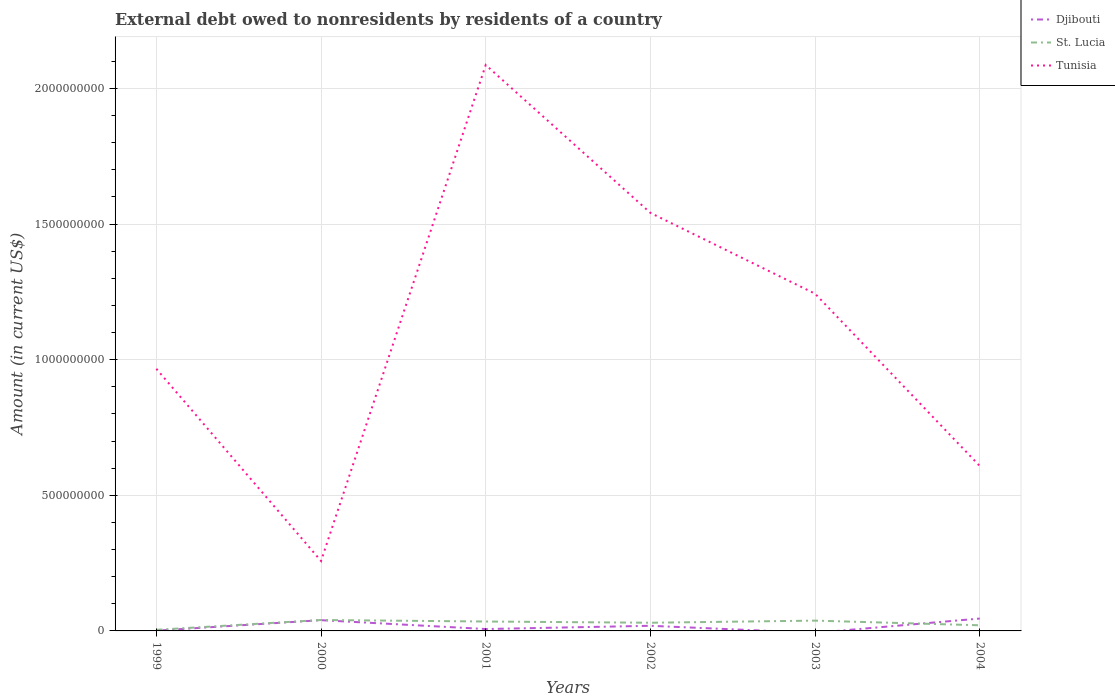Does the line corresponding to Tunisia intersect with the line corresponding to Djibouti?
Your answer should be very brief. No. Across all years, what is the maximum external debt owed by residents in Djibouti?
Offer a very short reply. 0. What is the total external debt owed by residents in St. Lucia in the graph?
Keep it short and to the point. 9.38e+06. What is the difference between the highest and the second highest external debt owed by residents in Tunisia?
Make the answer very short. 1.83e+09. What is the difference between the highest and the lowest external debt owed by residents in Tunisia?
Offer a terse response. 3. How are the legend labels stacked?
Your answer should be compact. Vertical. What is the title of the graph?
Keep it short and to the point. External debt owed to nonresidents by residents of a country. Does "Mauritius" appear as one of the legend labels in the graph?
Keep it short and to the point. No. What is the Amount (in current US$) of Djibouti in 1999?
Ensure brevity in your answer.  9.88e+05. What is the Amount (in current US$) in St. Lucia in 1999?
Your answer should be compact. 4.06e+06. What is the Amount (in current US$) in Tunisia in 1999?
Provide a succinct answer. 9.67e+08. What is the Amount (in current US$) of Djibouti in 2000?
Your response must be concise. 3.97e+07. What is the Amount (in current US$) in St. Lucia in 2000?
Provide a succinct answer. 4.03e+07. What is the Amount (in current US$) of Tunisia in 2000?
Offer a terse response. 2.58e+08. What is the Amount (in current US$) in Djibouti in 2001?
Offer a terse response. 6.98e+06. What is the Amount (in current US$) in St. Lucia in 2001?
Provide a short and direct response. 3.47e+07. What is the Amount (in current US$) in Tunisia in 2001?
Your answer should be very brief. 2.09e+09. What is the Amount (in current US$) in Djibouti in 2002?
Give a very brief answer. 1.89e+07. What is the Amount (in current US$) in St. Lucia in 2002?
Keep it short and to the point. 3.02e+07. What is the Amount (in current US$) of Tunisia in 2002?
Provide a short and direct response. 1.54e+09. What is the Amount (in current US$) in St. Lucia in 2003?
Offer a very short reply. 3.80e+07. What is the Amount (in current US$) of Tunisia in 2003?
Offer a terse response. 1.24e+09. What is the Amount (in current US$) in Djibouti in 2004?
Your response must be concise. 4.57e+07. What is the Amount (in current US$) in St. Lucia in 2004?
Your answer should be compact. 2.08e+07. What is the Amount (in current US$) of Tunisia in 2004?
Provide a succinct answer. 6.08e+08. Across all years, what is the maximum Amount (in current US$) in Djibouti?
Offer a very short reply. 4.57e+07. Across all years, what is the maximum Amount (in current US$) in St. Lucia?
Your response must be concise. 4.03e+07. Across all years, what is the maximum Amount (in current US$) in Tunisia?
Your answer should be compact. 2.09e+09. Across all years, what is the minimum Amount (in current US$) in St. Lucia?
Give a very brief answer. 4.06e+06. Across all years, what is the minimum Amount (in current US$) in Tunisia?
Keep it short and to the point. 2.58e+08. What is the total Amount (in current US$) in Djibouti in the graph?
Give a very brief answer. 1.12e+08. What is the total Amount (in current US$) of St. Lucia in the graph?
Provide a succinct answer. 1.68e+08. What is the total Amount (in current US$) in Tunisia in the graph?
Offer a terse response. 6.70e+09. What is the difference between the Amount (in current US$) of Djibouti in 1999 and that in 2000?
Make the answer very short. -3.87e+07. What is the difference between the Amount (in current US$) of St. Lucia in 1999 and that in 2000?
Make the answer very short. -3.62e+07. What is the difference between the Amount (in current US$) in Tunisia in 1999 and that in 2000?
Offer a very short reply. 7.09e+08. What is the difference between the Amount (in current US$) of Djibouti in 1999 and that in 2001?
Make the answer very short. -5.99e+06. What is the difference between the Amount (in current US$) of St. Lucia in 1999 and that in 2001?
Provide a short and direct response. -3.06e+07. What is the difference between the Amount (in current US$) in Tunisia in 1999 and that in 2001?
Your response must be concise. -1.12e+09. What is the difference between the Amount (in current US$) in Djibouti in 1999 and that in 2002?
Keep it short and to the point. -1.79e+07. What is the difference between the Amount (in current US$) in St. Lucia in 1999 and that in 2002?
Your answer should be compact. -2.61e+07. What is the difference between the Amount (in current US$) in Tunisia in 1999 and that in 2002?
Offer a very short reply. -5.75e+08. What is the difference between the Amount (in current US$) of St. Lucia in 1999 and that in 2003?
Give a very brief answer. -3.39e+07. What is the difference between the Amount (in current US$) in Tunisia in 1999 and that in 2003?
Your response must be concise. -2.77e+08. What is the difference between the Amount (in current US$) of Djibouti in 1999 and that in 2004?
Provide a succinct answer. -4.47e+07. What is the difference between the Amount (in current US$) in St. Lucia in 1999 and that in 2004?
Your answer should be compact. -1.67e+07. What is the difference between the Amount (in current US$) in Tunisia in 1999 and that in 2004?
Make the answer very short. 3.59e+08. What is the difference between the Amount (in current US$) in Djibouti in 2000 and that in 2001?
Offer a very short reply. 3.27e+07. What is the difference between the Amount (in current US$) in St. Lucia in 2000 and that in 2001?
Your response must be concise. 5.59e+06. What is the difference between the Amount (in current US$) of Tunisia in 2000 and that in 2001?
Give a very brief answer. -1.83e+09. What is the difference between the Amount (in current US$) of Djibouti in 2000 and that in 2002?
Offer a very short reply. 2.08e+07. What is the difference between the Amount (in current US$) of St. Lucia in 2000 and that in 2002?
Give a very brief answer. 1.01e+07. What is the difference between the Amount (in current US$) of Tunisia in 2000 and that in 2002?
Your response must be concise. -1.28e+09. What is the difference between the Amount (in current US$) of St. Lucia in 2000 and that in 2003?
Keep it short and to the point. 2.31e+06. What is the difference between the Amount (in current US$) of Tunisia in 2000 and that in 2003?
Your response must be concise. -9.85e+08. What is the difference between the Amount (in current US$) in Djibouti in 2000 and that in 2004?
Offer a very short reply. -6.00e+06. What is the difference between the Amount (in current US$) in St. Lucia in 2000 and that in 2004?
Your answer should be very brief. 1.95e+07. What is the difference between the Amount (in current US$) of Tunisia in 2000 and that in 2004?
Offer a terse response. -3.50e+08. What is the difference between the Amount (in current US$) of Djibouti in 2001 and that in 2002?
Offer a very short reply. -1.19e+07. What is the difference between the Amount (in current US$) of St. Lucia in 2001 and that in 2002?
Your answer should be compact. 4.52e+06. What is the difference between the Amount (in current US$) of Tunisia in 2001 and that in 2002?
Give a very brief answer. 5.45e+08. What is the difference between the Amount (in current US$) in St. Lucia in 2001 and that in 2003?
Your answer should be very brief. -3.28e+06. What is the difference between the Amount (in current US$) of Tunisia in 2001 and that in 2003?
Your answer should be compact. 8.43e+08. What is the difference between the Amount (in current US$) of Djibouti in 2001 and that in 2004?
Keep it short and to the point. -3.87e+07. What is the difference between the Amount (in current US$) of St. Lucia in 2001 and that in 2004?
Offer a terse response. 1.39e+07. What is the difference between the Amount (in current US$) of Tunisia in 2001 and that in 2004?
Offer a very short reply. 1.48e+09. What is the difference between the Amount (in current US$) of St. Lucia in 2002 and that in 2003?
Offer a very short reply. -7.80e+06. What is the difference between the Amount (in current US$) of Tunisia in 2002 and that in 2003?
Ensure brevity in your answer.  2.98e+08. What is the difference between the Amount (in current US$) in Djibouti in 2002 and that in 2004?
Your answer should be compact. -2.68e+07. What is the difference between the Amount (in current US$) in St. Lucia in 2002 and that in 2004?
Provide a short and direct response. 9.38e+06. What is the difference between the Amount (in current US$) in Tunisia in 2002 and that in 2004?
Offer a very short reply. 9.33e+08. What is the difference between the Amount (in current US$) in St. Lucia in 2003 and that in 2004?
Provide a succinct answer. 1.72e+07. What is the difference between the Amount (in current US$) in Tunisia in 2003 and that in 2004?
Offer a terse response. 6.35e+08. What is the difference between the Amount (in current US$) in Djibouti in 1999 and the Amount (in current US$) in St. Lucia in 2000?
Your answer should be compact. -3.93e+07. What is the difference between the Amount (in current US$) of Djibouti in 1999 and the Amount (in current US$) of Tunisia in 2000?
Provide a succinct answer. -2.57e+08. What is the difference between the Amount (in current US$) in St. Lucia in 1999 and the Amount (in current US$) in Tunisia in 2000?
Make the answer very short. -2.54e+08. What is the difference between the Amount (in current US$) in Djibouti in 1999 and the Amount (in current US$) in St. Lucia in 2001?
Give a very brief answer. -3.37e+07. What is the difference between the Amount (in current US$) in Djibouti in 1999 and the Amount (in current US$) in Tunisia in 2001?
Ensure brevity in your answer.  -2.09e+09. What is the difference between the Amount (in current US$) in St. Lucia in 1999 and the Amount (in current US$) in Tunisia in 2001?
Your answer should be compact. -2.08e+09. What is the difference between the Amount (in current US$) of Djibouti in 1999 and the Amount (in current US$) of St. Lucia in 2002?
Give a very brief answer. -2.92e+07. What is the difference between the Amount (in current US$) in Djibouti in 1999 and the Amount (in current US$) in Tunisia in 2002?
Keep it short and to the point. -1.54e+09. What is the difference between the Amount (in current US$) of St. Lucia in 1999 and the Amount (in current US$) of Tunisia in 2002?
Keep it short and to the point. -1.54e+09. What is the difference between the Amount (in current US$) of Djibouti in 1999 and the Amount (in current US$) of St. Lucia in 2003?
Ensure brevity in your answer.  -3.70e+07. What is the difference between the Amount (in current US$) of Djibouti in 1999 and the Amount (in current US$) of Tunisia in 2003?
Give a very brief answer. -1.24e+09. What is the difference between the Amount (in current US$) of St. Lucia in 1999 and the Amount (in current US$) of Tunisia in 2003?
Make the answer very short. -1.24e+09. What is the difference between the Amount (in current US$) in Djibouti in 1999 and the Amount (in current US$) in St. Lucia in 2004?
Provide a short and direct response. -1.98e+07. What is the difference between the Amount (in current US$) in Djibouti in 1999 and the Amount (in current US$) in Tunisia in 2004?
Offer a terse response. -6.07e+08. What is the difference between the Amount (in current US$) of St. Lucia in 1999 and the Amount (in current US$) of Tunisia in 2004?
Offer a terse response. -6.04e+08. What is the difference between the Amount (in current US$) in Djibouti in 2000 and the Amount (in current US$) in St. Lucia in 2001?
Keep it short and to the point. 4.96e+06. What is the difference between the Amount (in current US$) in Djibouti in 2000 and the Amount (in current US$) in Tunisia in 2001?
Make the answer very short. -2.05e+09. What is the difference between the Amount (in current US$) in St. Lucia in 2000 and the Amount (in current US$) in Tunisia in 2001?
Ensure brevity in your answer.  -2.05e+09. What is the difference between the Amount (in current US$) of Djibouti in 2000 and the Amount (in current US$) of St. Lucia in 2002?
Ensure brevity in your answer.  9.48e+06. What is the difference between the Amount (in current US$) in Djibouti in 2000 and the Amount (in current US$) in Tunisia in 2002?
Your answer should be compact. -1.50e+09. What is the difference between the Amount (in current US$) of St. Lucia in 2000 and the Amount (in current US$) of Tunisia in 2002?
Offer a very short reply. -1.50e+09. What is the difference between the Amount (in current US$) of Djibouti in 2000 and the Amount (in current US$) of St. Lucia in 2003?
Make the answer very short. 1.68e+06. What is the difference between the Amount (in current US$) in Djibouti in 2000 and the Amount (in current US$) in Tunisia in 2003?
Provide a succinct answer. -1.20e+09. What is the difference between the Amount (in current US$) of St. Lucia in 2000 and the Amount (in current US$) of Tunisia in 2003?
Your answer should be compact. -1.20e+09. What is the difference between the Amount (in current US$) of Djibouti in 2000 and the Amount (in current US$) of St. Lucia in 2004?
Provide a succinct answer. 1.89e+07. What is the difference between the Amount (in current US$) of Djibouti in 2000 and the Amount (in current US$) of Tunisia in 2004?
Give a very brief answer. -5.68e+08. What is the difference between the Amount (in current US$) of St. Lucia in 2000 and the Amount (in current US$) of Tunisia in 2004?
Ensure brevity in your answer.  -5.68e+08. What is the difference between the Amount (in current US$) in Djibouti in 2001 and the Amount (in current US$) in St. Lucia in 2002?
Make the answer very short. -2.32e+07. What is the difference between the Amount (in current US$) in Djibouti in 2001 and the Amount (in current US$) in Tunisia in 2002?
Offer a very short reply. -1.53e+09. What is the difference between the Amount (in current US$) in St. Lucia in 2001 and the Amount (in current US$) in Tunisia in 2002?
Offer a terse response. -1.51e+09. What is the difference between the Amount (in current US$) of Djibouti in 2001 and the Amount (in current US$) of St. Lucia in 2003?
Your answer should be compact. -3.10e+07. What is the difference between the Amount (in current US$) in Djibouti in 2001 and the Amount (in current US$) in Tunisia in 2003?
Your answer should be compact. -1.24e+09. What is the difference between the Amount (in current US$) of St. Lucia in 2001 and the Amount (in current US$) of Tunisia in 2003?
Your answer should be compact. -1.21e+09. What is the difference between the Amount (in current US$) of Djibouti in 2001 and the Amount (in current US$) of St. Lucia in 2004?
Make the answer very short. -1.38e+07. What is the difference between the Amount (in current US$) in Djibouti in 2001 and the Amount (in current US$) in Tunisia in 2004?
Provide a short and direct response. -6.01e+08. What is the difference between the Amount (in current US$) of St. Lucia in 2001 and the Amount (in current US$) of Tunisia in 2004?
Provide a short and direct response. -5.73e+08. What is the difference between the Amount (in current US$) in Djibouti in 2002 and the Amount (in current US$) in St. Lucia in 2003?
Provide a succinct answer. -1.91e+07. What is the difference between the Amount (in current US$) of Djibouti in 2002 and the Amount (in current US$) of Tunisia in 2003?
Provide a short and direct response. -1.22e+09. What is the difference between the Amount (in current US$) in St. Lucia in 2002 and the Amount (in current US$) in Tunisia in 2003?
Offer a terse response. -1.21e+09. What is the difference between the Amount (in current US$) in Djibouti in 2002 and the Amount (in current US$) in St. Lucia in 2004?
Your answer should be compact. -1.90e+06. What is the difference between the Amount (in current US$) in Djibouti in 2002 and the Amount (in current US$) in Tunisia in 2004?
Give a very brief answer. -5.89e+08. What is the difference between the Amount (in current US$) in St. Lucia in 2002 and the Amount (in current US$) in Tunisia in 2004?
Give a very brief answer. -5.78e+08. What is the difference between the Amount (in current US$) in St. Lucia in 2003 and the Amount (in current US$) in Tunisia in 2004?
Give a very brief answer. -5.70e+08. What is the average Amount (in current US$) in Djibouti per year?
Keep it short and to the point. 1.87e+07. What is the average Amount (in current US$) in St. Lucia per year?
Make the answer very short. 2.80e+07. What is the average Amount (in current US$) of Tunisia per year?
Provide a short and direct response. 1.12e+09. In the year 1999, what is the difference between the Amount (in current US$) in Djibouti and Amount (in current US$) in St. Lucia?
Your answer should be very brief. -3.08e+06. In the year 1999, what is the difference between the Amount (in current US$) in Djibouti and Amount (in current US$) in Tunisia?
Offer a very short reply. -9.66e+08. In the year 1999, what is the difference between the Amount (in current US$) of St. Lucia and Amount (in current US$) of Tunisia?
Your response must be concise. -9.62e+08. In the year 2000, what is the difference between the Amount (in current US$) in Djibouti and Amount (in current US$) in St. Lucia?
Give a very brief answer. -6.26e+05. In the year 2000, what is the difference between the Amount (in current US$) of Djibouti and Amount (in current US$) of Tunisia?
Offer a very short reply. -2.18e+08. In the year 2000, what is the difference between the Amount (in current US$) of St. Lucia and Amount (in current US$) of Tunisia?
Your answer should be very brief. -2.18e+08. In the year 2001, what is the difference between the Amount (in current US$) of Djibouti and Amount (in current US$) of St. Lucia?
Offer a very short reply. -2.77e+07. In the year 2001, what is the difference between the Amount (in current US$) of Djibouti and Amount (in current US$) of Tunisia?
Make the answer very short. -2.08e+09. In the year 2001, what is the difference between the Amount (in current US$) of St. Lucia and Amount (in current US$) of Tunisia?
Your answer should be very brief. -2.05e+09. In the year 2002, what is the difference between the Amount (in current US$) of Djibouti and Amount (in current US$) of St. Lucia?
Provide a short and direct response. -1.13e+07. In the year 2002, what is the difference between the Amount (in current US$) in Djibouti and Amount (in current US$) in Tunisia?
Your answer should be compact. -1.52e+09. In the year 2002, what is the difference between the Amount (in current US$) in St. Lucia and Amount (in current US$) in Tunisia?
Ensure brevity in your answer.  -1.51e+09. In the year 2003, what is the difference between the Amount (in current US$) of St. Lucia and Amount (in current US$) of Tunisia?
Your answer should be very brief. -1.21e+09. In the year 2004, what is the difference between the Amount (in current US$) of Djibouti and Amount (in current US$) of St. Lucia?
Give a very brief answer. 2.49e+07. In the year 2004, what is the difference between the Amount (in current US$) in Djibouti and Amount (in current US$) in Tunisia?
Make the answer very short. -5.62e+08. In the year 2004, what is the difference between the Amount (in current US$) in St. Lucia and Amount (in current US$) in Tunisia?
Provide a short and direct response. -5.87e+08. What is the ratio of the Amount (in current US$) in Djibouti in 1999 to that in 2000?
Give a very brief answer. 0.02. What is the ratio of the Amount (in current US$) in St. Lucia in 1999 to that in 2000?
Ensure brevity in your answer.  0.1. What is the ratio of the Amount (in current US$) of Tunisia in 1999 to that in 2000?
Give a very brief answer. 3.75. What is the ratio of the Amount (in current US$) in Djibouti in 1999 to that in 2001?
Your answer should be compact. 0.14. What is the ratio of the Amount (in current US$) of St. Lucia in 1999 to that in 2001?
Your answer should be compact. 0.12. What is the ratio of the Amount (in current US$) in Tunisia in 1999 to that in 2001?
Offer a very short reply. 0.46. What is the ratio of the Amount (in current US$) in Djibouti in 1999 to that in 2002?
Offer a terse response. 0.05. What is the ratio of the Amount (in current US$) of St. Lucia in 1999 to that in 2002?
Provide a short and direct response. 0.13. What is the ratio of the Amount (in current US$) of Tunisia in 1999 to that in 2002?
Your response must be concise. 0.63. What is the ratio of the Amount (in current US$) of St. Lucia in 1999 to that in 2003?
Your answer should be compact. 0.11. What is the ratio of the Amount (in current US$) in Tunisia in 1999 to that in 2003?
Your response must be concise. 0.78. What is the ratio of the Amount (in current US$) of Djibouti in 1999 to that in 2004?
Your answer should be very brief. 0.02. What is the ratio of the Amount (in current US$) of St. Lucia in 1999 to that in 2004?
Your answer should be compact. 0.2. What is the ratio of the Amount (in current US$) in Tunisia in 1999 to that in 2004?
Ensure brevity in your answer.  1.59. What is the ratio of the Amount (in current US$) of Djibouti in 2000 to that in 2001?
Make the answer very short. 5.68. What is the ratio of the Amount (in current US$) in St. Lucia in 2000 to that in 2001?
Make the answer very short. 1.16. What is the ratio of the Amount (in current US$) of Tunisia in 2000 to that in 2001?
Provide a short and direct response. 0.12. What is the ratio of the Amount (in current US$) in Djibouti in 2000 to that in 2002?
Keep it short and to the point. 2.1. What is the ratio of the Amount (in current US$) of St. Lucia in 2000 to that in 2002?
Make the answer very short. 1.33. What is the ratio of the Amount (in current US$) in Tunisia in 2000 to that in 2002?
Give a very brief answer. 0.17. What is the ratio of the Amount (in current US$) in St. Lucia in 2000 to that in 2003?
Your response must be concise. 1.06. What is the ratio of the Amount (in current US$) of Tunisia in 2000 to that in 2003?
Ensure brevity in your answer.  0.21. What is the ratio of the Amount (in current US$) in Djibouti in 2000 to that in 2004?
Make the answer very short. 0.87. What is the ratio of the Amount (in current US$) in St. Lucia in 2000 to that in 2004?
Ensure brevity in your answer.  1.94. What is the ratio of the Amount (in current US$) of Tunisia in 2000 to that in 2004?
Your response must be concise. 0.42. What is the ratio of the Amount (in current US$) of Djibouti in 2001 to that in 2002?
Provide a short and direct response. 0.37. What is the ratio of the Amount (in current US$) in St. Lucia in 2001 to that in 2002?
Make the answer very short. 1.15. What is the ratio of the Amount (in current US$) of Tunisia in 2001 to that in 2002?
Ensure brevity in your answer.  1.35. What is the ratio of the Amount (in current US$) in St. Lucia in 2001 to that in 2003?
Provide a succinct answer. 0.91. What is the ratio of the Amount (in current US$) in Tunisia in 2001 to that in 2003?
Make the answer very short. 1.68. What is the ratio of the Amount (in current US$) of Djibouti in 2001 to that in 2004?
Ensure brevity in your answer.  0.15. What is the ratio of the Amount (in current US$) in St. Lucia in 2001 to that in 2004?
Provide a short and direct response. 1.67. What is the ratio of the Amount (in current US$) of Tunisia in 2001 to that in 2004?
Provide a succinct answer. 3.43. What is the ratio of the Amount (in current US$) in St. Lucia in 2002 to that in 2003?
Keep it short and to the point. 0.79. What is the ratio of the Amount (in current US$) in Tunisia in 2002 to that in 2003?
Ensure brevity in your answer.  1.24. What is the ratio of the Amount (in current US$) in Djibouti in 2002 to that in 2004?
Offer a terse response. 0.41. What is the ratio of the Amount (in current US$) in St. Lucia in 2002 to that in 2004?
Your response must be concise. 1.45. What is the ratio of the Amount (in current US$) of Tunisia in 2002 to that in 2004?
Offer a terse response. 2.54. What is the ratio of the Amount (in current US$) in St. Lucia in 2003 to that in 2004?
Make the answer very short. 1.83. What is the ratio of the Amount (in current US$) in Tunisia in 2003 to that in 2004?
Provide a short and direct response. 2.05. What is the difference between the highest and the second highest Amount (in current US$) in Djibouti?
Give a very brief answer. 6.00e+06. What is the difference between the highest and the second highest Amount (in current US$) in St. Lucia?
Make the answer very short. 2.31e+06. What is the difference between the highest and the second highest Amount (in current US$) of Tunisia?
Provide a short and direct response. 5.45e+08. What is the difference between the highest and the lowest Amount (in current US$) of Djibouti?
Ensure brevity in your answer.  4.57e+07. What is the difference between the highest and the lowest Amount (in current US$) in St. Lucia?
Your answer should be very brief. 3.62e+07. What is the difference between the highest and the lowest Amount (in current US$) in Tunisia?
Keep it short and to the point. 1.83e+09. 